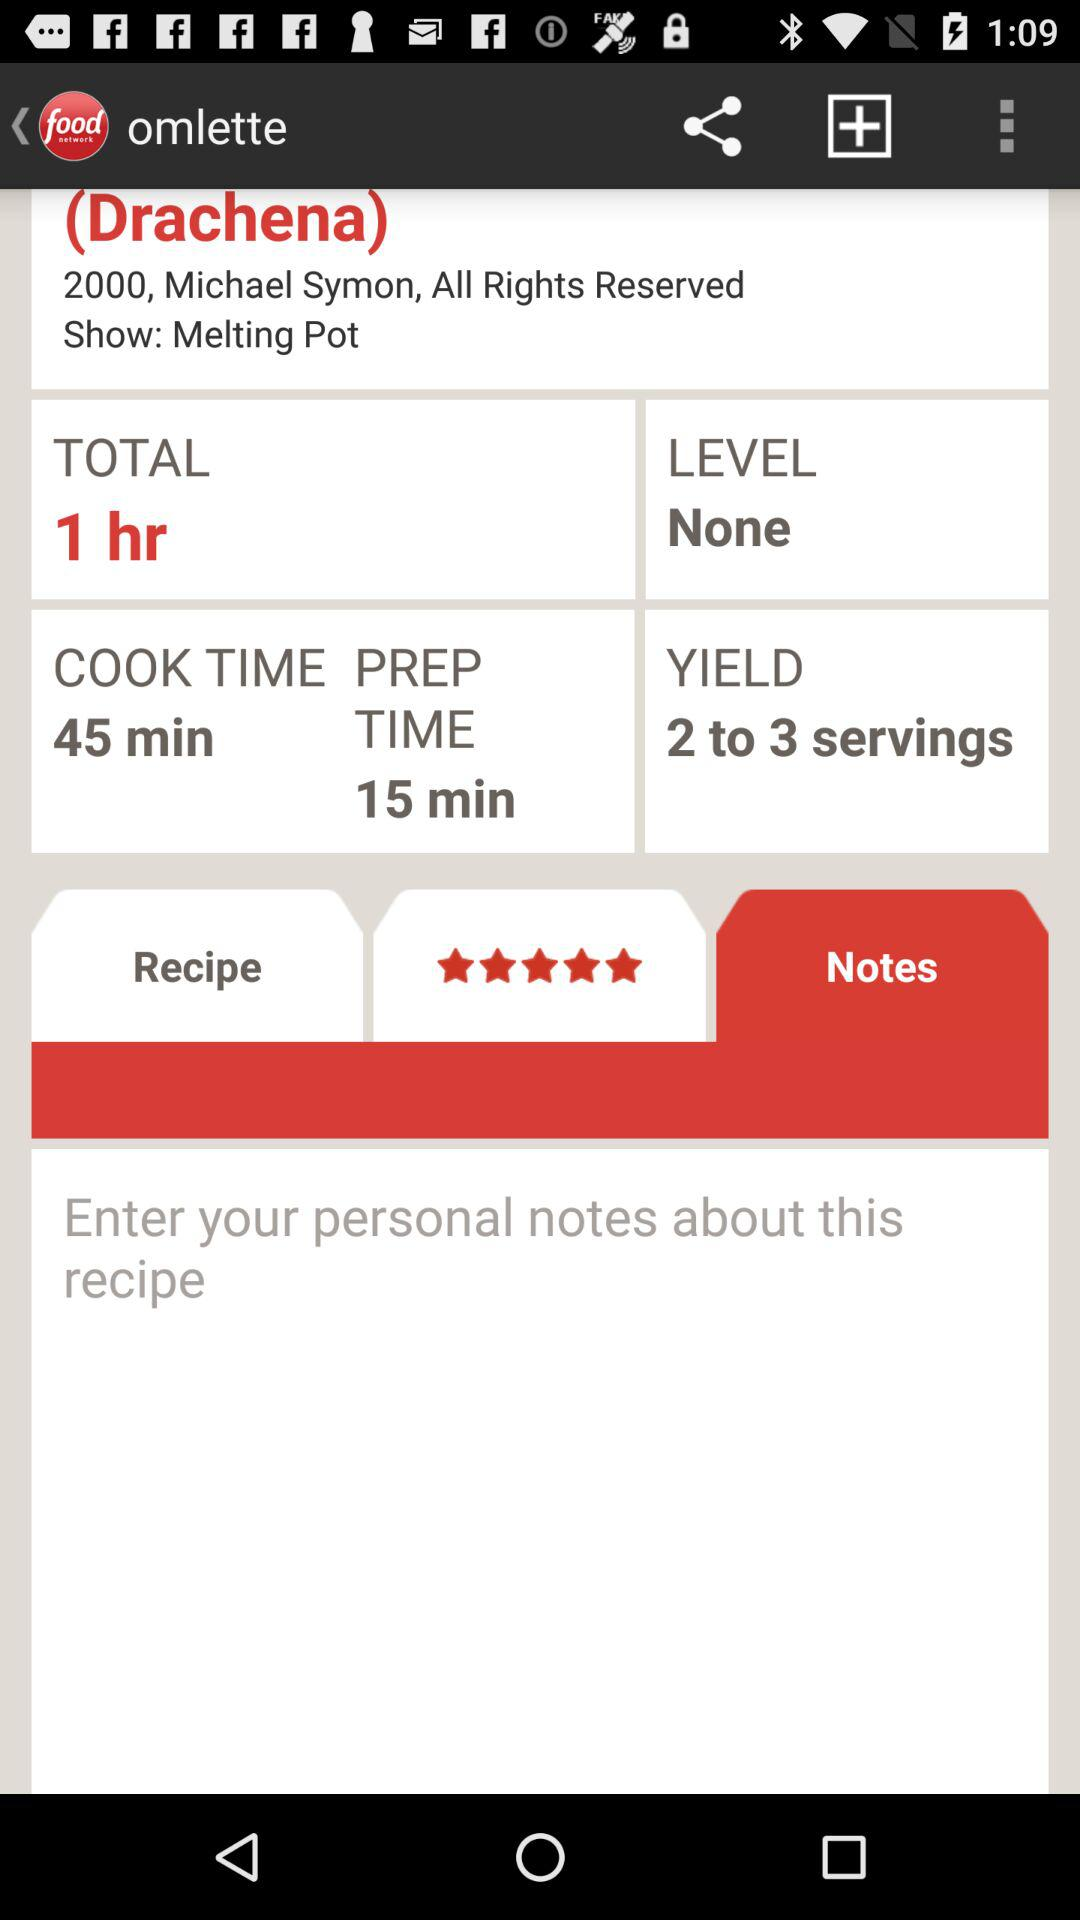What is the rating? The rating is 5 stars. 